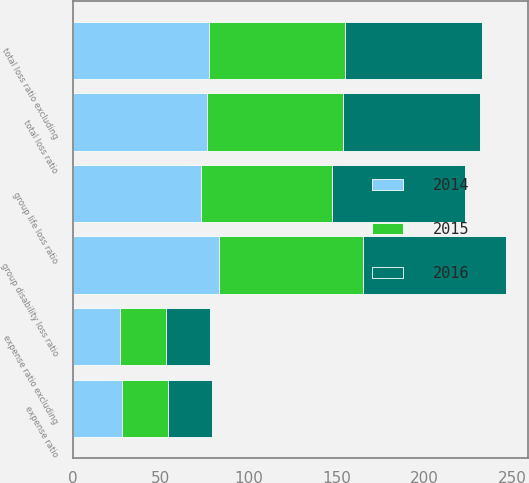<chart> <loc_0><loc_0><loc_500><loc_500><stacked_bar_chart><ecel><fcel>group disability loss ratio<fcel>group life loss ratio<fcel>total loss ratio<fcel>expense ratio<fcel>total loss ratio excluding<fcel>expense ratio excluding<nl><fcel>2016<fcel>81.4<fcel>75.7<fcel>78<fcel>25.1<fcel>78<fcel>25.1<nl><fcel>2015<fcel>81.6<fcel>74.7<fcel>77.4<fcel>26.1<fcel>77.4<fcel>26.1<nl><fcel>2014<fcel>83.5<fcel>72.8<fcel>76.2<fcel>28.2<fcel>77.4<fcel>27.2<nl></chart> 